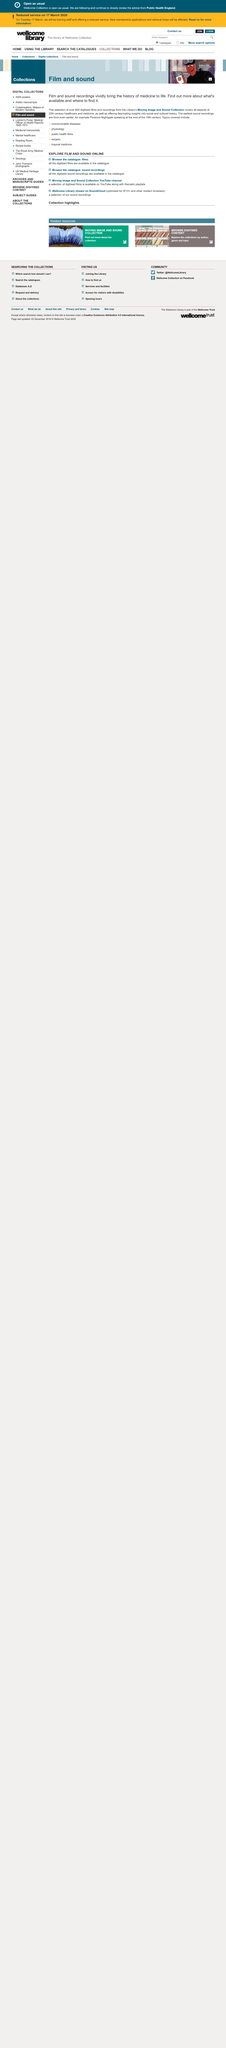List a handful of essential elements in this visual. Yes, the text states that film and sound bring the history of medicine to life. The library's collection covers all aspects of 20th century healthcare and medicine. Our collection includes over 600 digitized films and recordings, providing access to a vast array of information. 